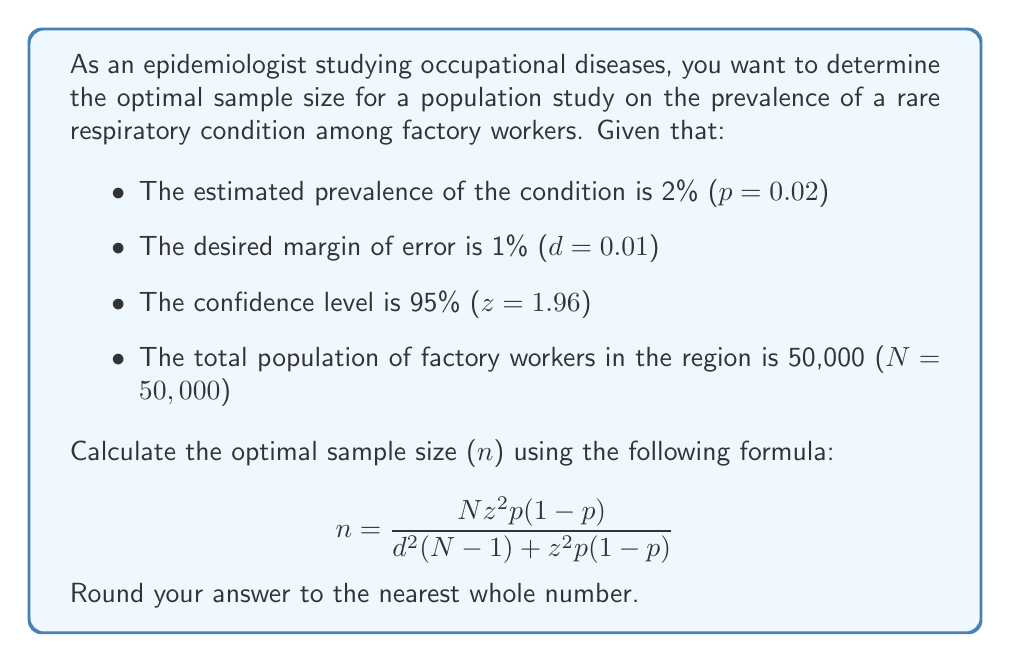Solve this math problem. To solve for the optimal sample size, we'll use the given formula and substitute the known values:

$$ n = \frac{N z^2 p(1-p)}{d^2(N-1) + z^2p(1-p)} $$

Where:
- N = 50,000 (total population)
- z = 1.96 (95% confidence level)
- p = 0.02 (estimated prevalence)
- d = 0.01 (desired margin of error)

Let's substitute these values into the formula:

$$ n = \frac{50,000 \times 1.96^2 \times 0.02(1-0.02)}{0.01^2(50,000-1) + 1.96^2 \times 0.02(1-0.02)} $$

Now, let's calculate step by step:

1. Calculate $z^2$:
   $1.96^2 = 3.8416$

2. Calculate $p(1-p)$:
   $0.02(1-0.02) = 0.02 \times 0.98 = 0.0196$

3. Calculate the numerator:
   $50,000 \times 3.8416 \times 0.0196 = 3,764.768$

4. Calculate $d^2$:
   $0.01^2 = 0.0001$

5. Calculate $(N-1)$:
   $50,000 - 1 = 49,999$

6. Calculate the denominator:
   $0.0001 \times 49,999 + 3.8416 \times 0.0196 = 4.99990 + 0.075295 = 5.075195$

7. Divide the numerator by the denominator:
   $3,764.768 \div 5.075195 = 741.8038$

8. Round to the nearest whole number:
   $742$

Therefore, the optimal sample size for this population study is 742 factory workers.
Answer: 742 